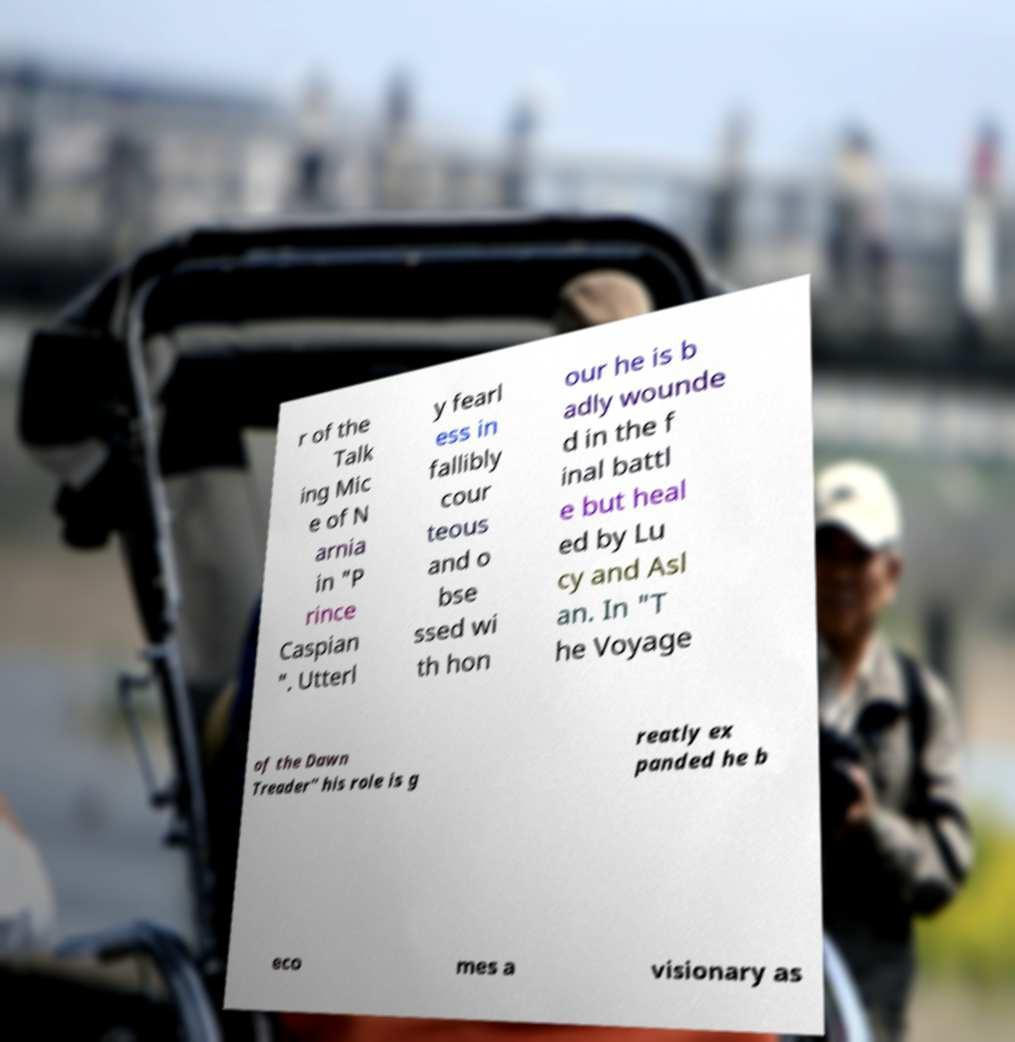Could you assist in decoding the text presented in this image and type it out clearly? r of the Talk ing Mic e of N arnia in "P rince Caspian ". Utterl y fearl ess in fallibly cour teous and o bse ssed wi th hon our he is b adly wounde d in the f inal battl e but heal ed by Lu cy and Asl an. In "T he Voyage of the Dawn Treader" his role is g reatly ex panded he b eco mes a visionary as 